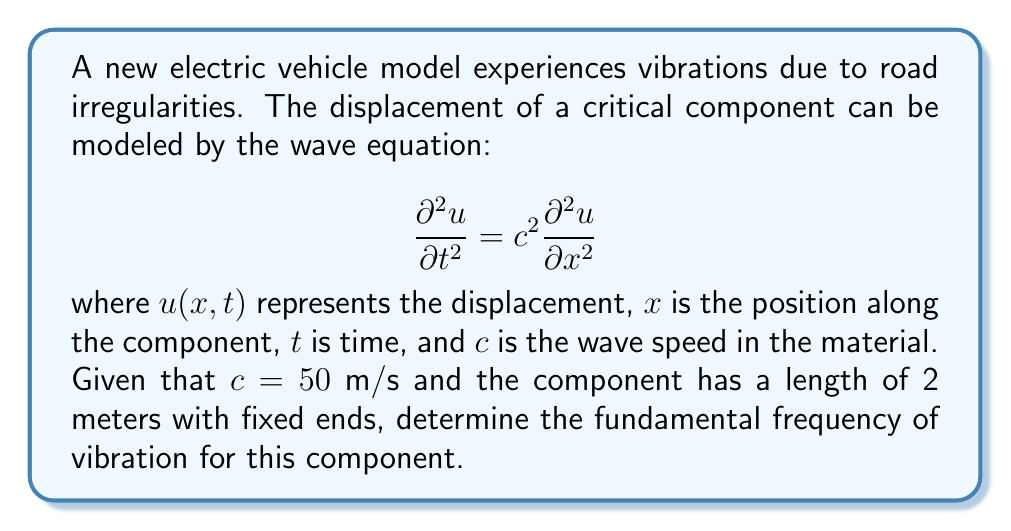Can you answer this question? To solve this problem, we'll follow these steps:

1) For a component with fixed ends, the general solution to the wave equation is:

   $$u(x,t) = \sum_{n=1}^{\infty} A_n \sin(\frac{n\pi x}{L}) \cos(\frac{n\pi c t}{L})$$

   where $L$ is the length of the component.

2) The fundamental frequency corresponds to $n=1$, so we focus on:

   $$u(x,t) = A_1 \sin(\frac{\pi x}{L}) \cos(\frac{\pi c t}{L})$$

3) The angular frequency $\omega$ is the coefficient of $t$ in the cosine term:

   $$\omega = \frac{\pi c}{L}$$

4) We can convert this to frequency $f$ using the relation $f = \frac{\omega}{2\pi}$:

   $$f = \frac{c}{2L}$$

5) Now, we can substitute the given values:
   $c = 50$ m/s
   $L = 2$ m

   $$f = \frac{50}{2(2)} = \frac{50}{4} = 12.5$$

Therefore, the fundamental frequency is 12.5 Hz.
Answer: 12.5 Hz 